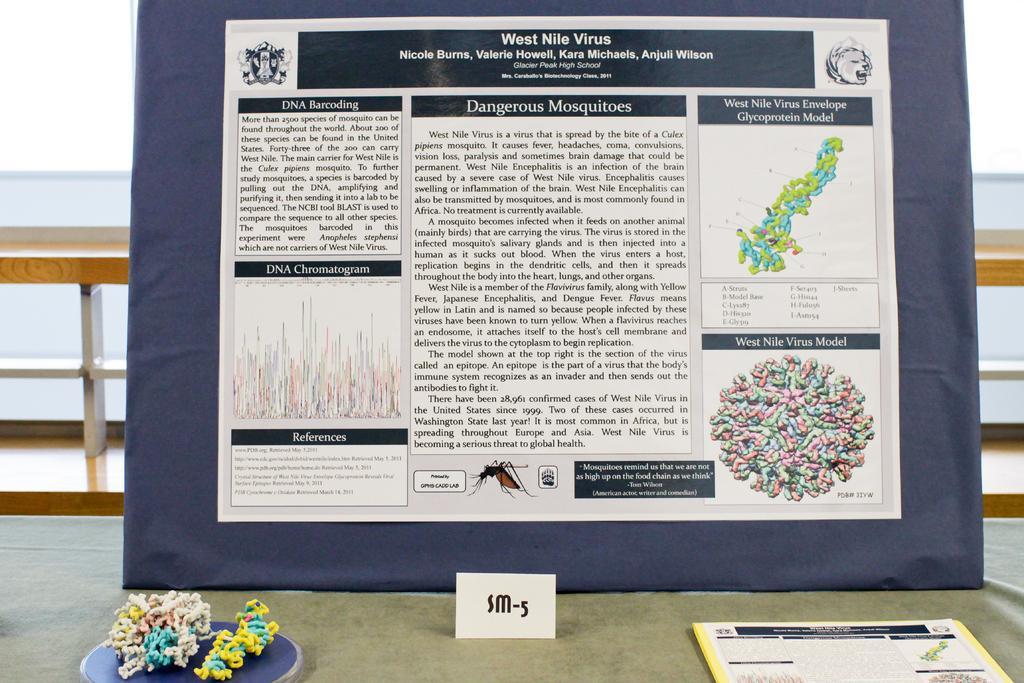Describe this image in one or two sentences. In the image there is a board with a printed paper on it, in front of it there is a book on the cloth, behind it there is wooden fence. 